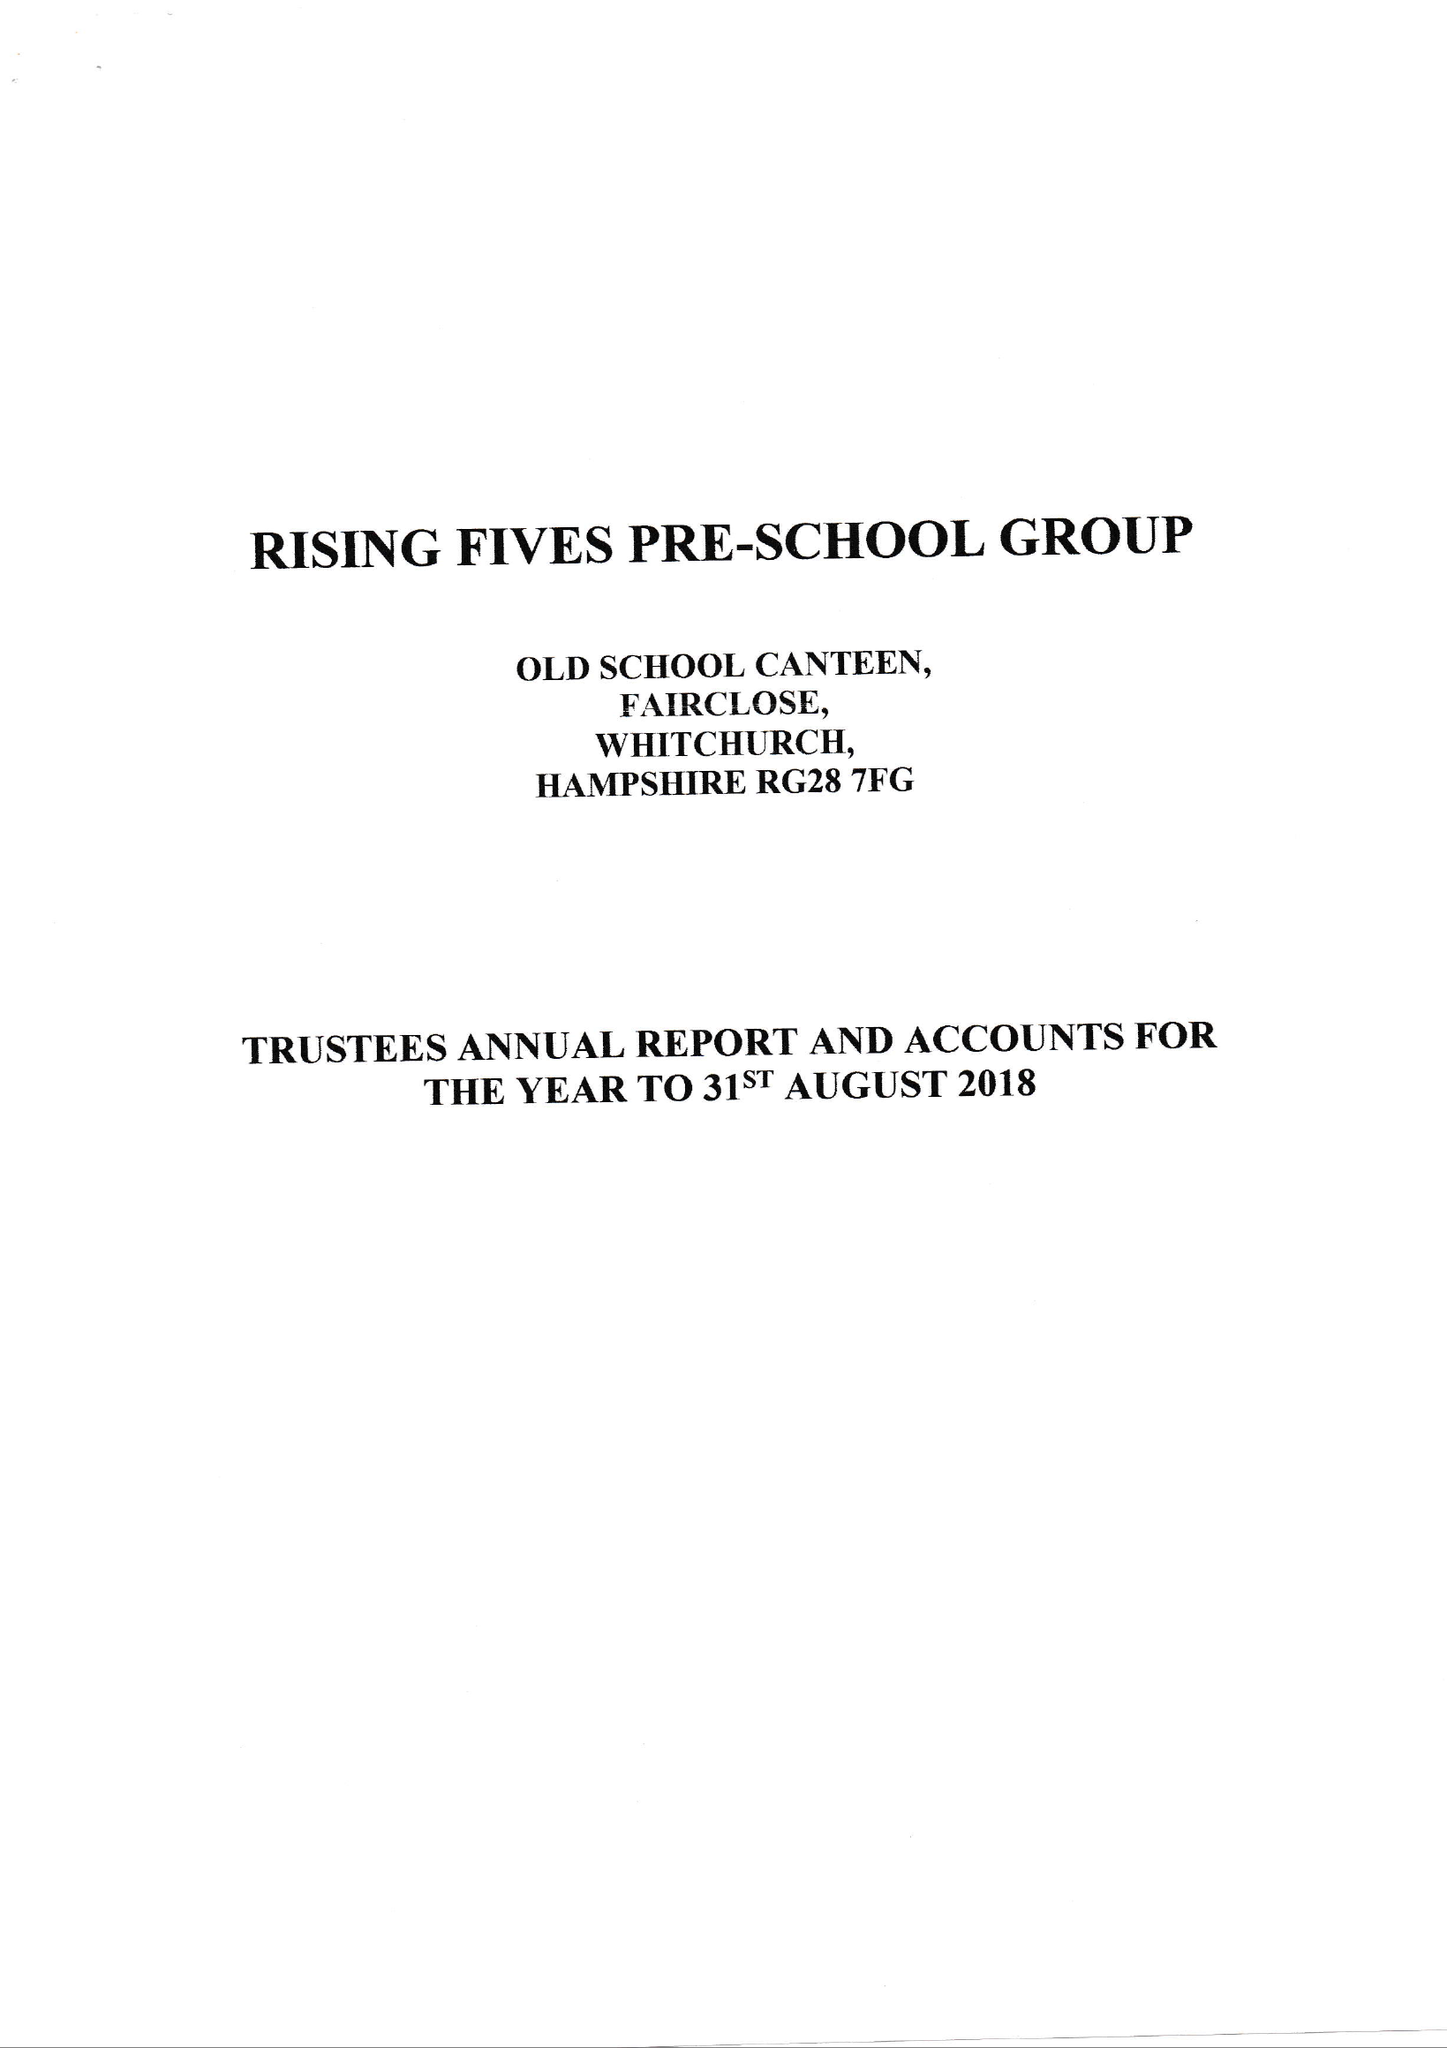What is the value for the spending_annually_in_british_pounds?
Answer the question using a single word or phrase. 80050.00 